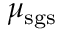<formula> <loc_0><loc_0><loc_500><loc_500>\mu _ { s g s }</formula> 